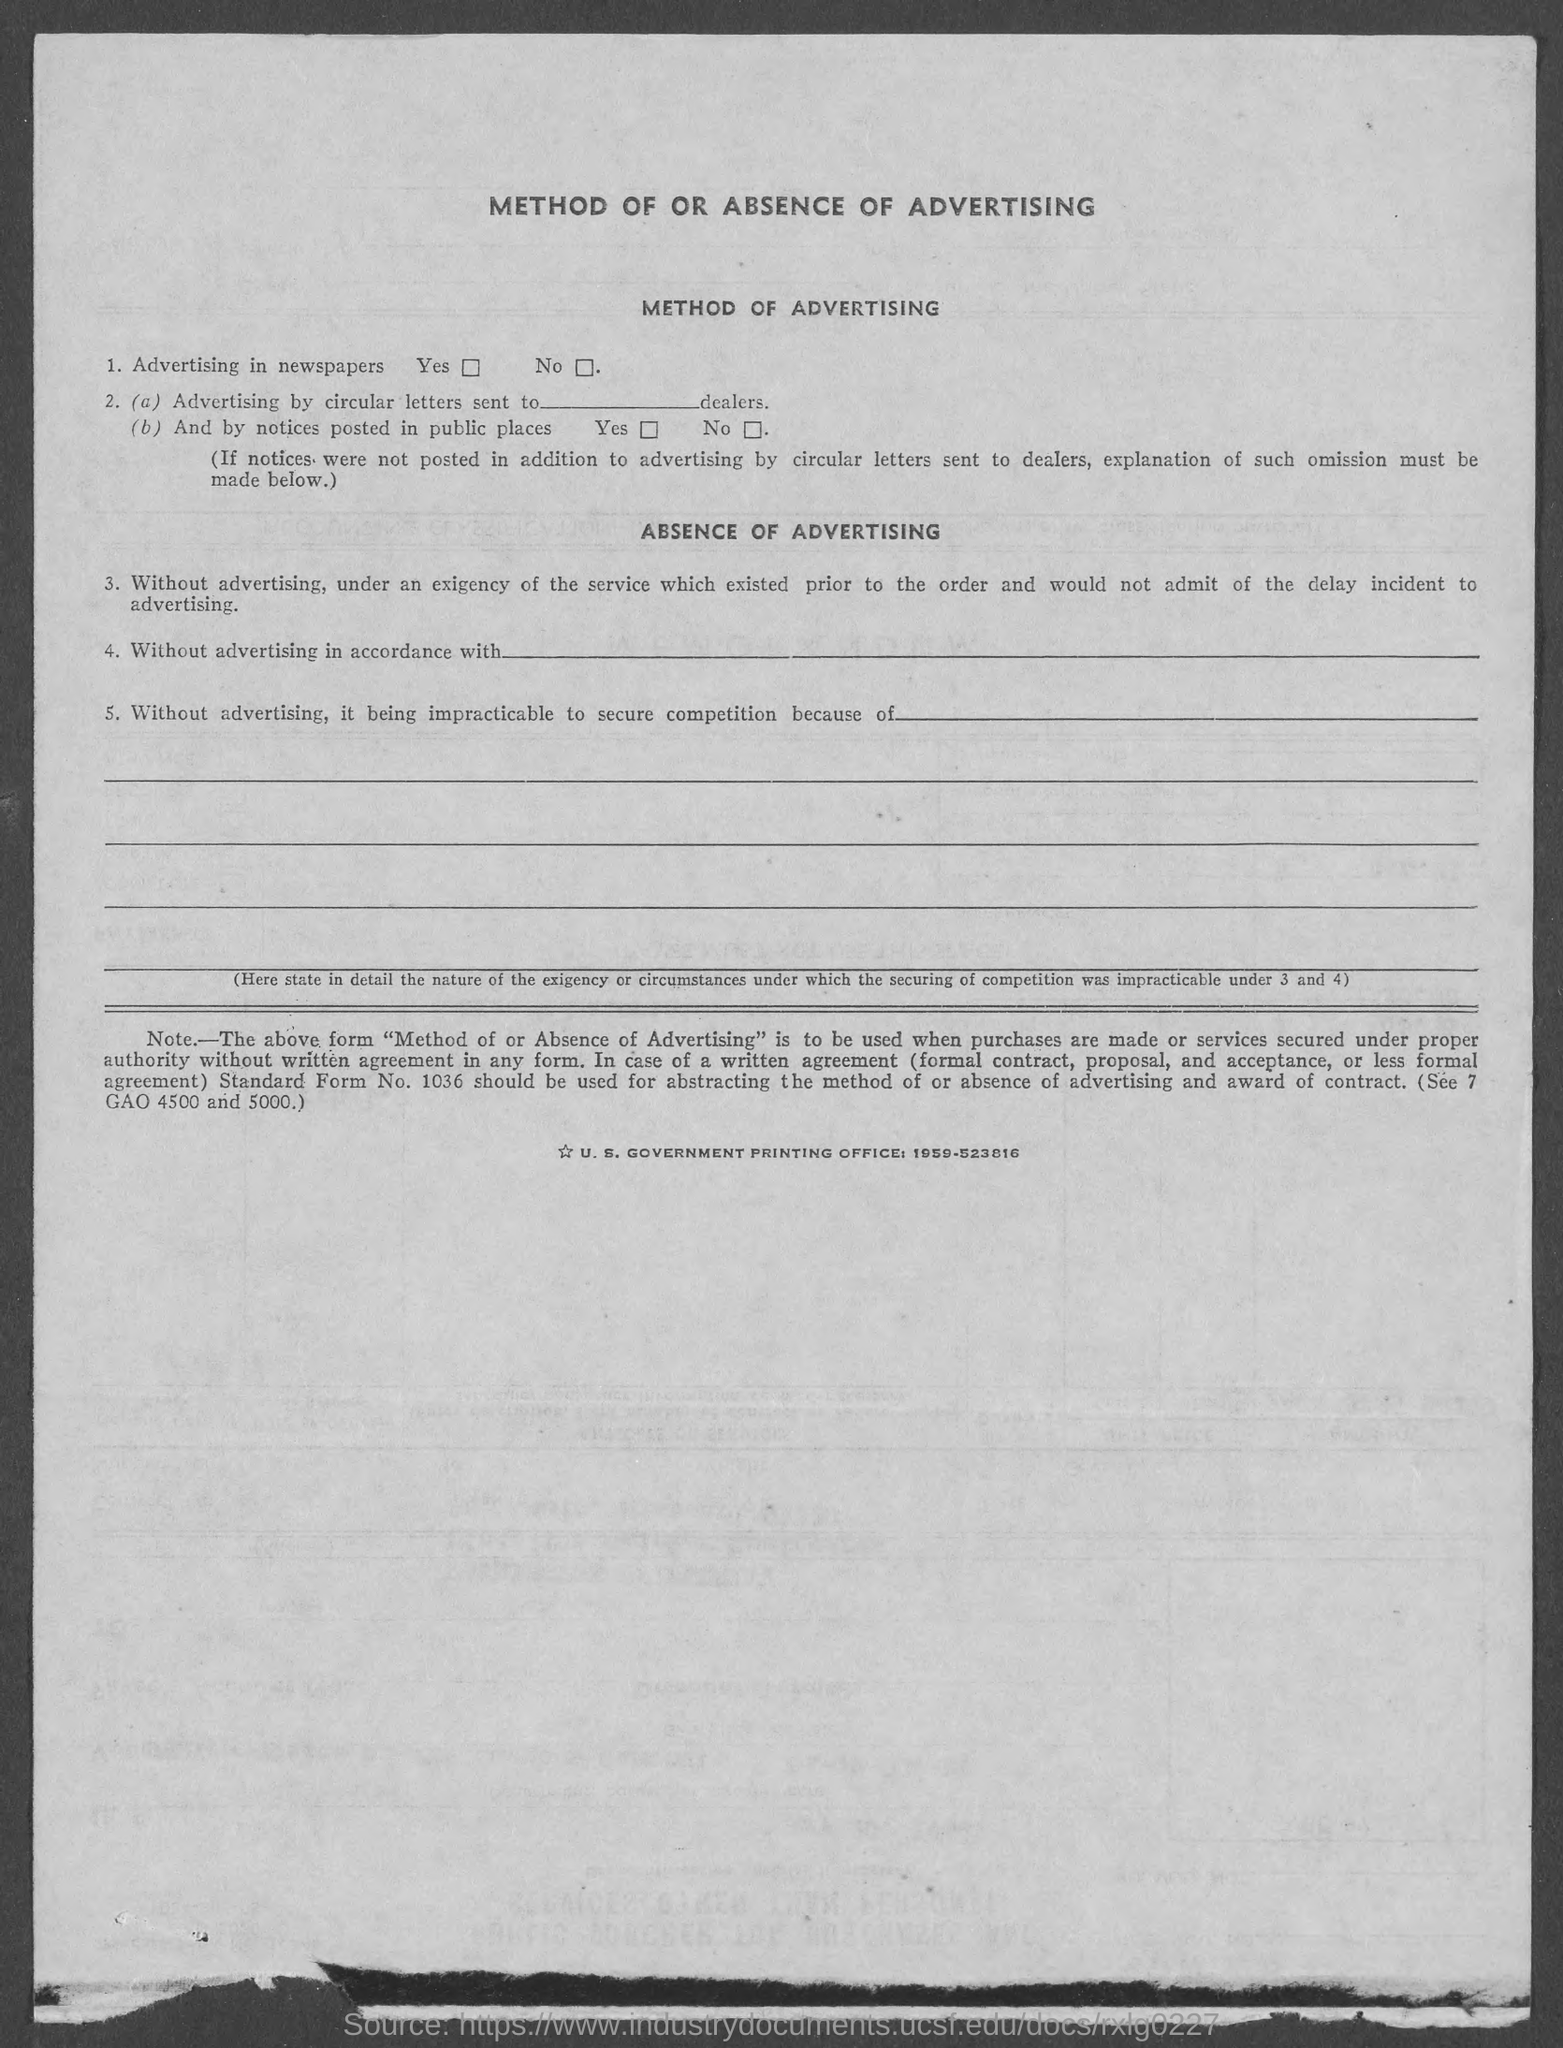What is the heading at top of  the page?
Provide a short and direct response. Method of or absence of Advertising. 